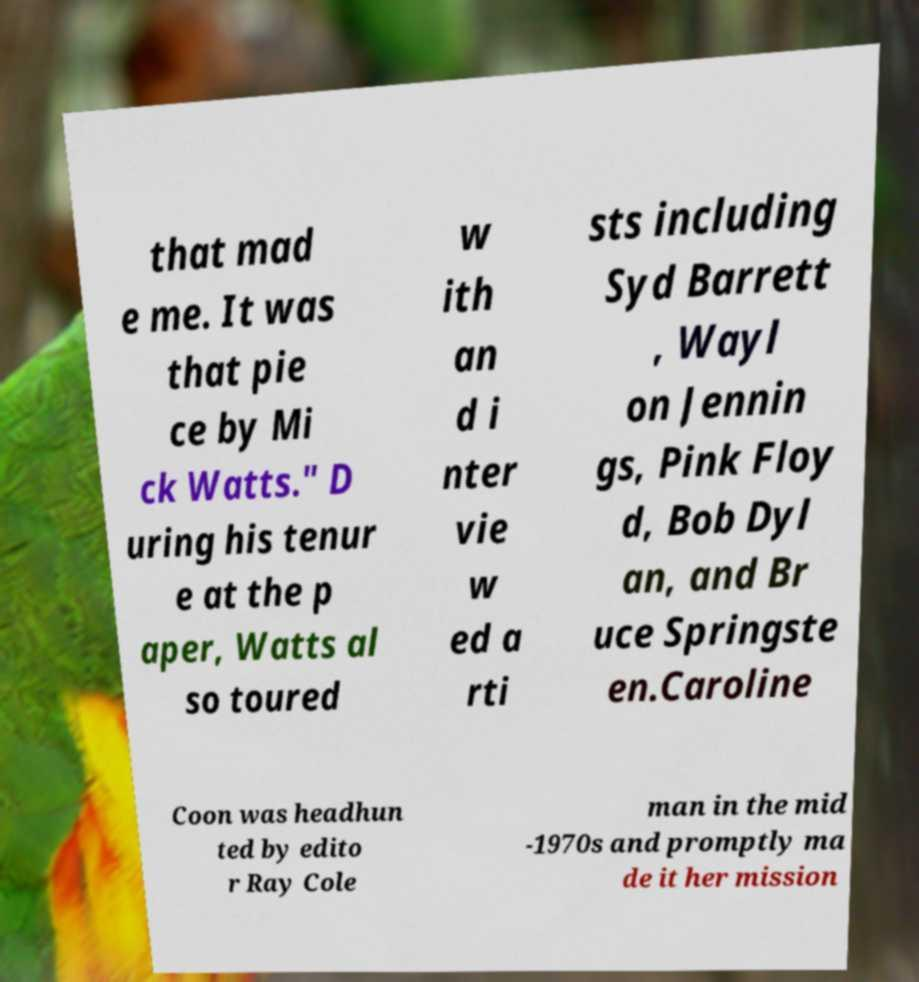Please read and relay the text visible in this image. What does it say? that mad e me. It was that pie ce by Mi ck Watts." D uring his tenur e at the p aper, Watts al so toured w ith an d i nter vie w ed a rti sts including Syd Barrett , Wayl on Jennin gs, Pink Floy d, Bob Dyl an, and Br uce Springste en.Caroline Coon was headhun ted by edito r Ray Cole man in the mid -1970s and promptly ma de it her mission 